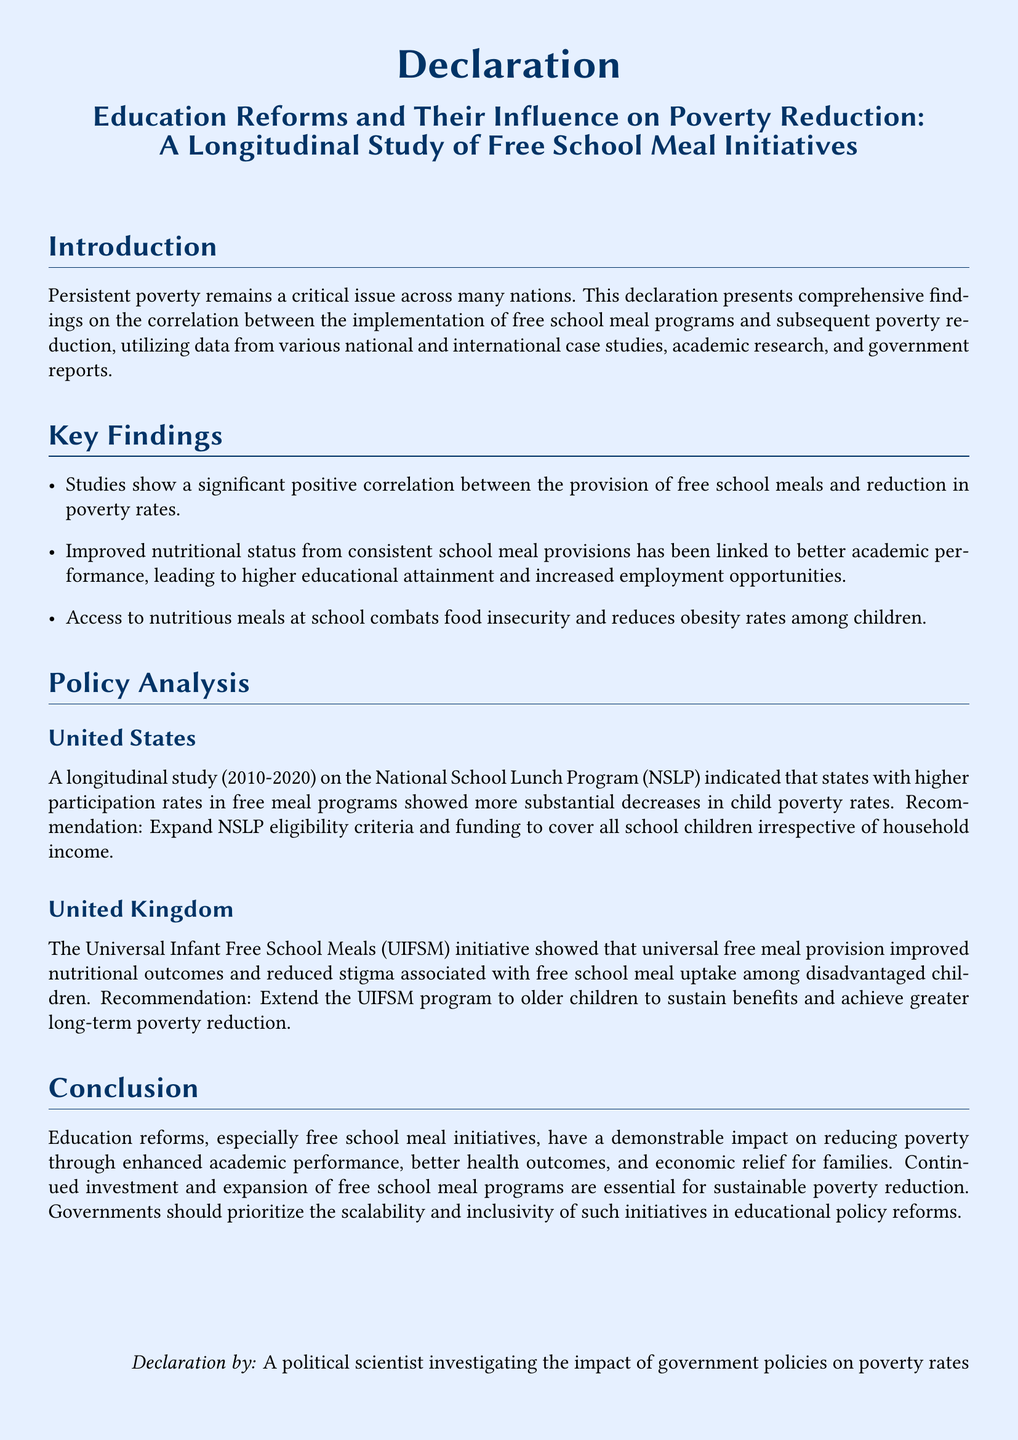What is the focus of this declaration? The focus of the declaration is on the correlation between free school meal programs and poverty reduction.
Answer: correlation between free school meal programs and poverty reduction What time period does the U.S. longitudinal study cover? The U.S. longitudinal study covers the years from 2010 to 2020.
Answer: 2010-2020 What initiative does the UK program relate to? The UK program relates to the Universal Infant Free School Meals (UIFSM) initiative.
Answer: Universal Infant Free School Meals (UIFSM) What is one key finding regarding free school meals? One key finding is that free school meals significantly reduce poverty rates.
Answer: significantly reduce poverty rates Which program showed a more substantial decrease in child poverty rates? The National School Lunch Program (NSLP) showed a more substantial decrease.
Answer: National School Lunch Program (NSLP) Which aspect of children's health does the document say is improved by access to school meals? Access to school meals combats food insecurity and reduces obesity rates among children.
Answer: combats food insecurity and reduces obesity rates What is a recommendation for the NSLP in the U.S.? The recommendation is to expand NSLP eligibility criteria and funding.
Answer: expand NSLP eligibility criteria and funding Who authored this declaration? The declaration was authored by a political scientist investigating the impact of government policies on poverty rates.
Answer: a political scientist investigating the impact of government policies on poverty rates 